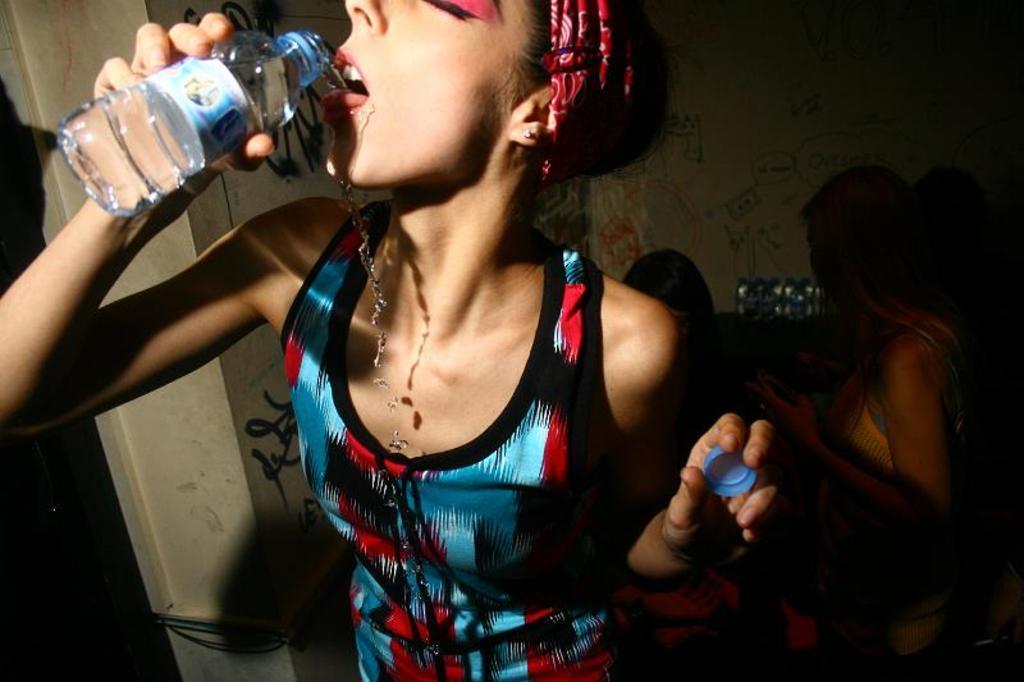Describe this image in one or two sentences. In this picture we can see a girl wearing a blue and red dress, standing in the front and drinking water with the bottle. Behind there is a woman and white wall.  